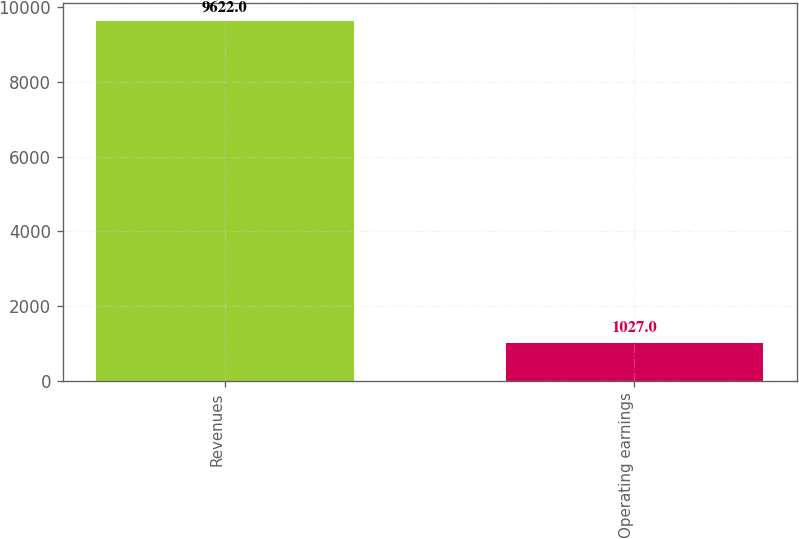Convert chart to OTSL. <chart><loc_0><loc_0><loc_500><loc_500><bar_chart><fcel>Revenues<fcel>Operating earnings<nl><fcel>9622<fcel>1027<nl></chart> 